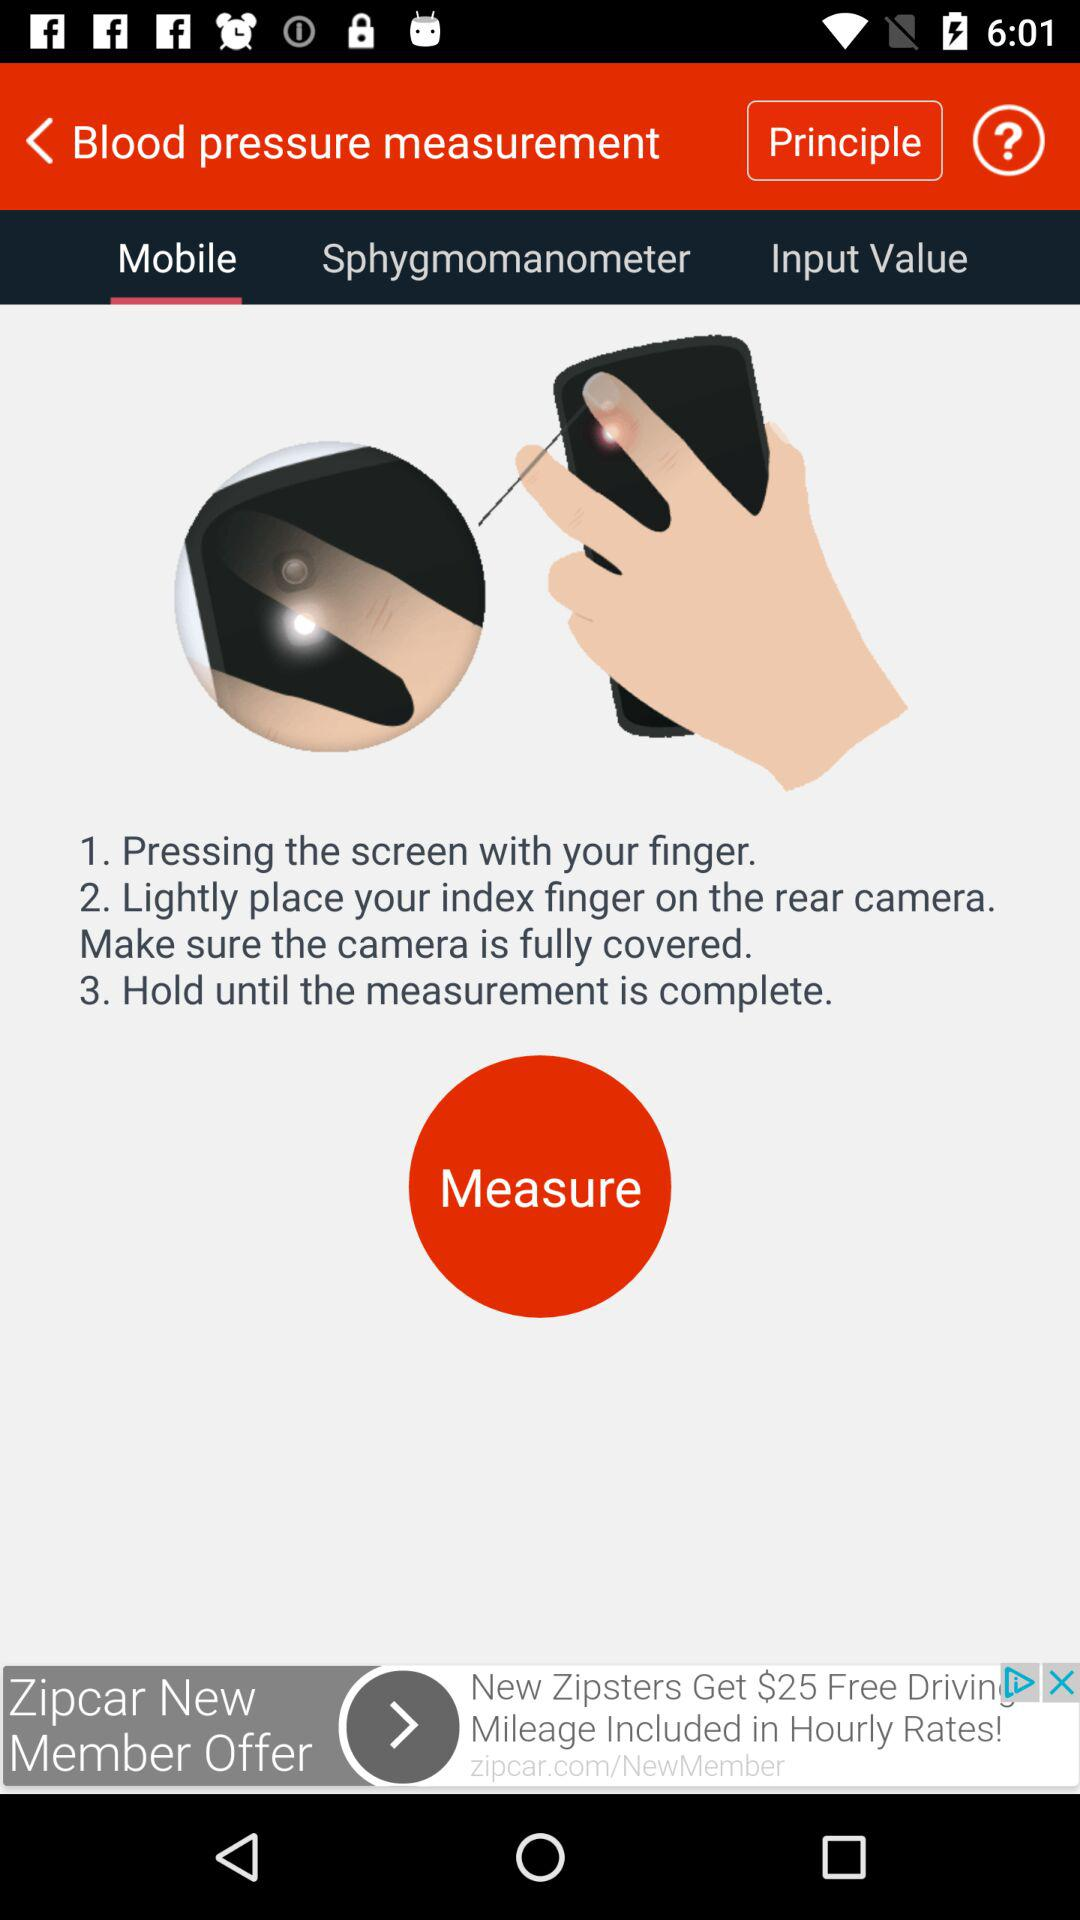How many steps are there in the instructions?
Answer the question using a single word or phrase. 3 